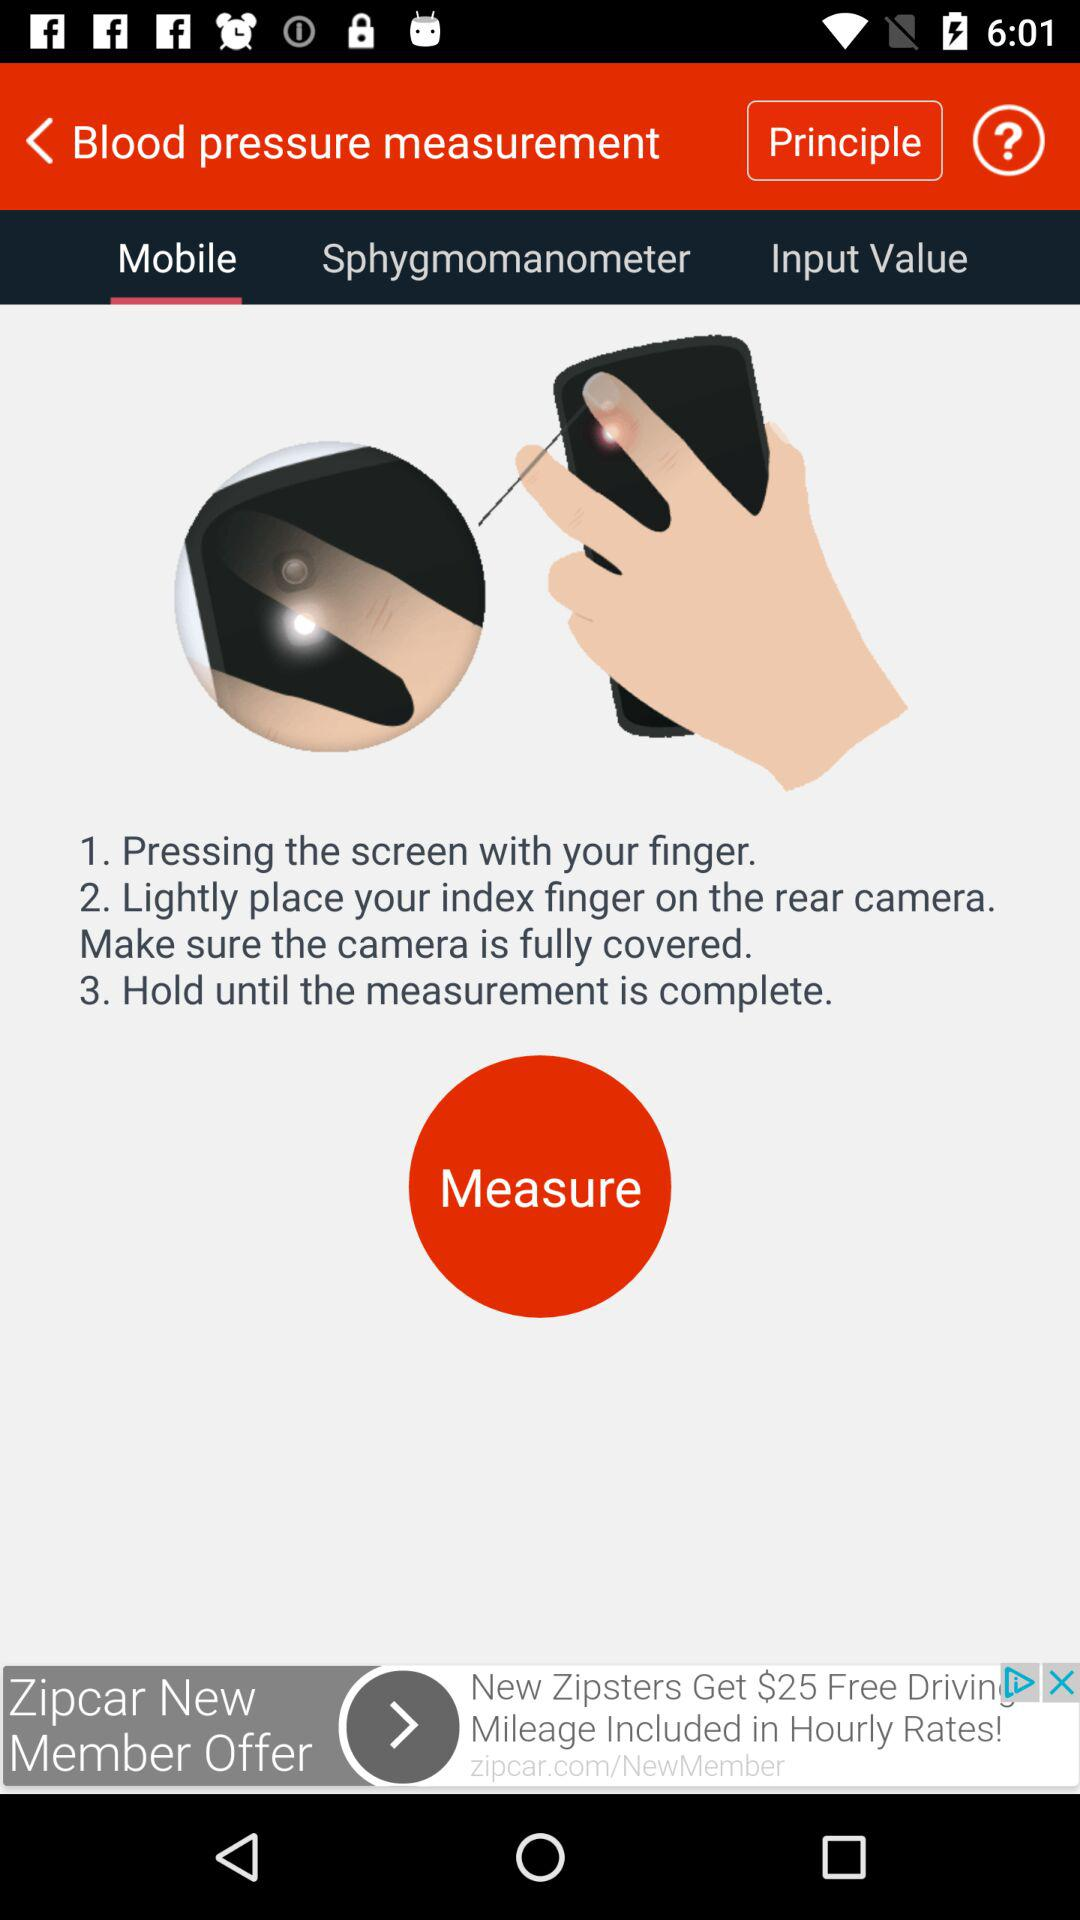How many steps are there in the instructions?
Answer the question using a single word or phrase. 3 